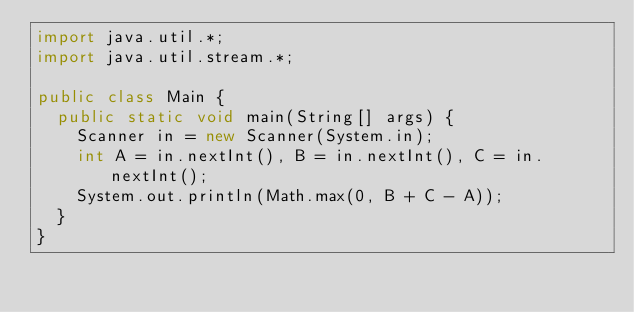<code> <loc_0><loc_0><loc_500><loc_500><_Java_>import java.util.*;
import java.util.stream.*;

public class Main {
  public static void main(String[] args) {
    Scanner in = new Scanner(System.in);
    int A = in.nextInt(), B = in.nextInt(), C = in.nextInt();
    System.out.println(Math.max(0, B + C - A));
  }
}
</code> 